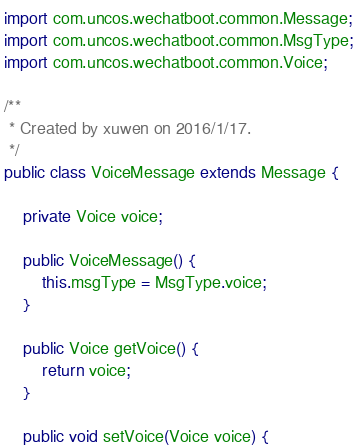Convert code to text. <code><loc_0><loc_0><loc_500><loc_500><_Java_>
import com.uncos.wechatboot.common.Message;
import com.uncos.wechatboot.common.MsgType;
import com.uncos.wechatboot.common.Voice;

/**
 * Created by xuwen on 2016/1/17.
 */
public class VoiceMessage extends Message {

    private Voice voice;

    public VoiceMessage() {
        this.msgType = MsgType.voice;
    }

    public Voice getVoice() {
        return voice;
    }

    public void setVoice(Voice voice) {</code> 